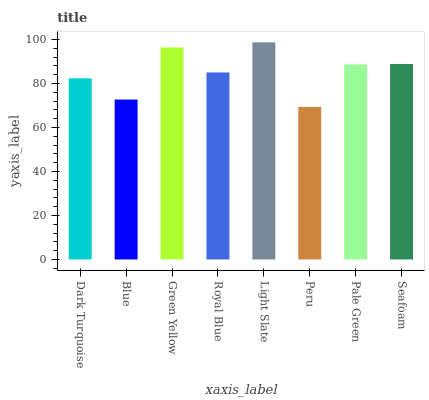Is Peru the minimum?
Answer yes or no. Yes. Is Light Slate the maximum?
Answer yes or no. Yes. Is Blue the minimum?
Answer yes or no. No. Is Blue the maximum?
Answer yes or no. No. Is Dark Turquoise greater than Blue?
Answer yes or no. Yes. Is Blue less than Dark Turquoise?
Answer yes or no. Yes. Is Blue greater than Dark Turquoise?
Answer yes or no. No. Is Dark Turquoise less than Blue?
Answer yes or no. No. Is Pale Green the high median?
Answer yes or no. Yes. Is Royal Blue the low median?
Answer yes or no. Yes. Is Light Slate the high median?
Answer yes or no. No. Is Blue the low median?
Answer yes or no. No. 